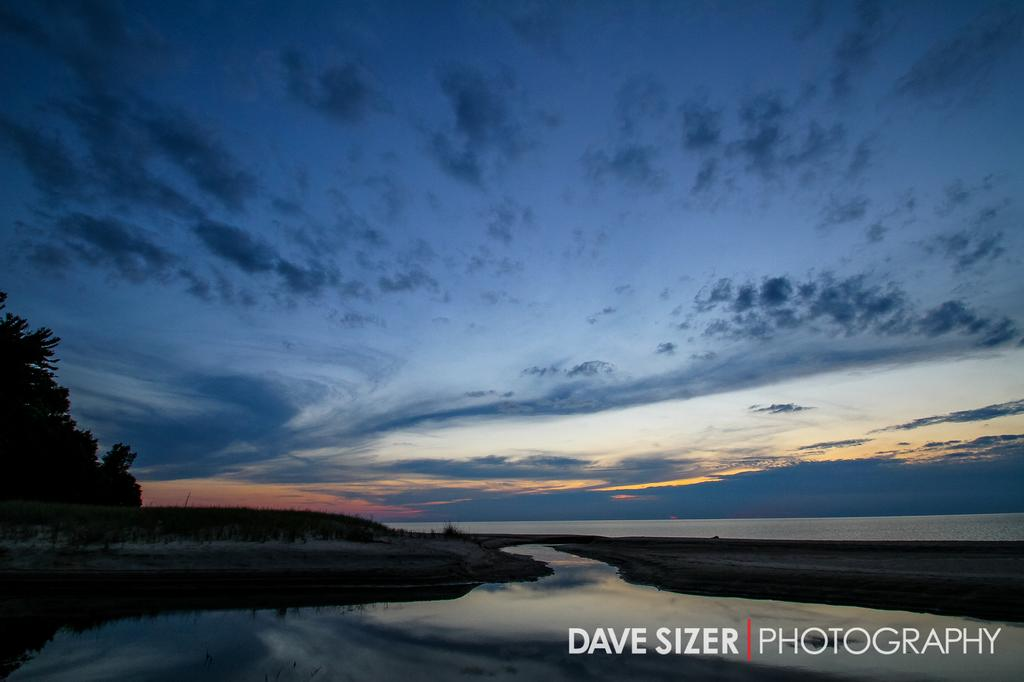What is the main feature of the image? The main feature of the image is water. What other natural elements can be seen in the image? There are trees and grass on the ground in the image. What is visible in the sky? The sky is visible in the image, and there are clouds present. Is there any text in the image? Yes, there is some text on the image. What type of punishment is being carried out on the plant in the image? There is no plant or punishment present in the image. 